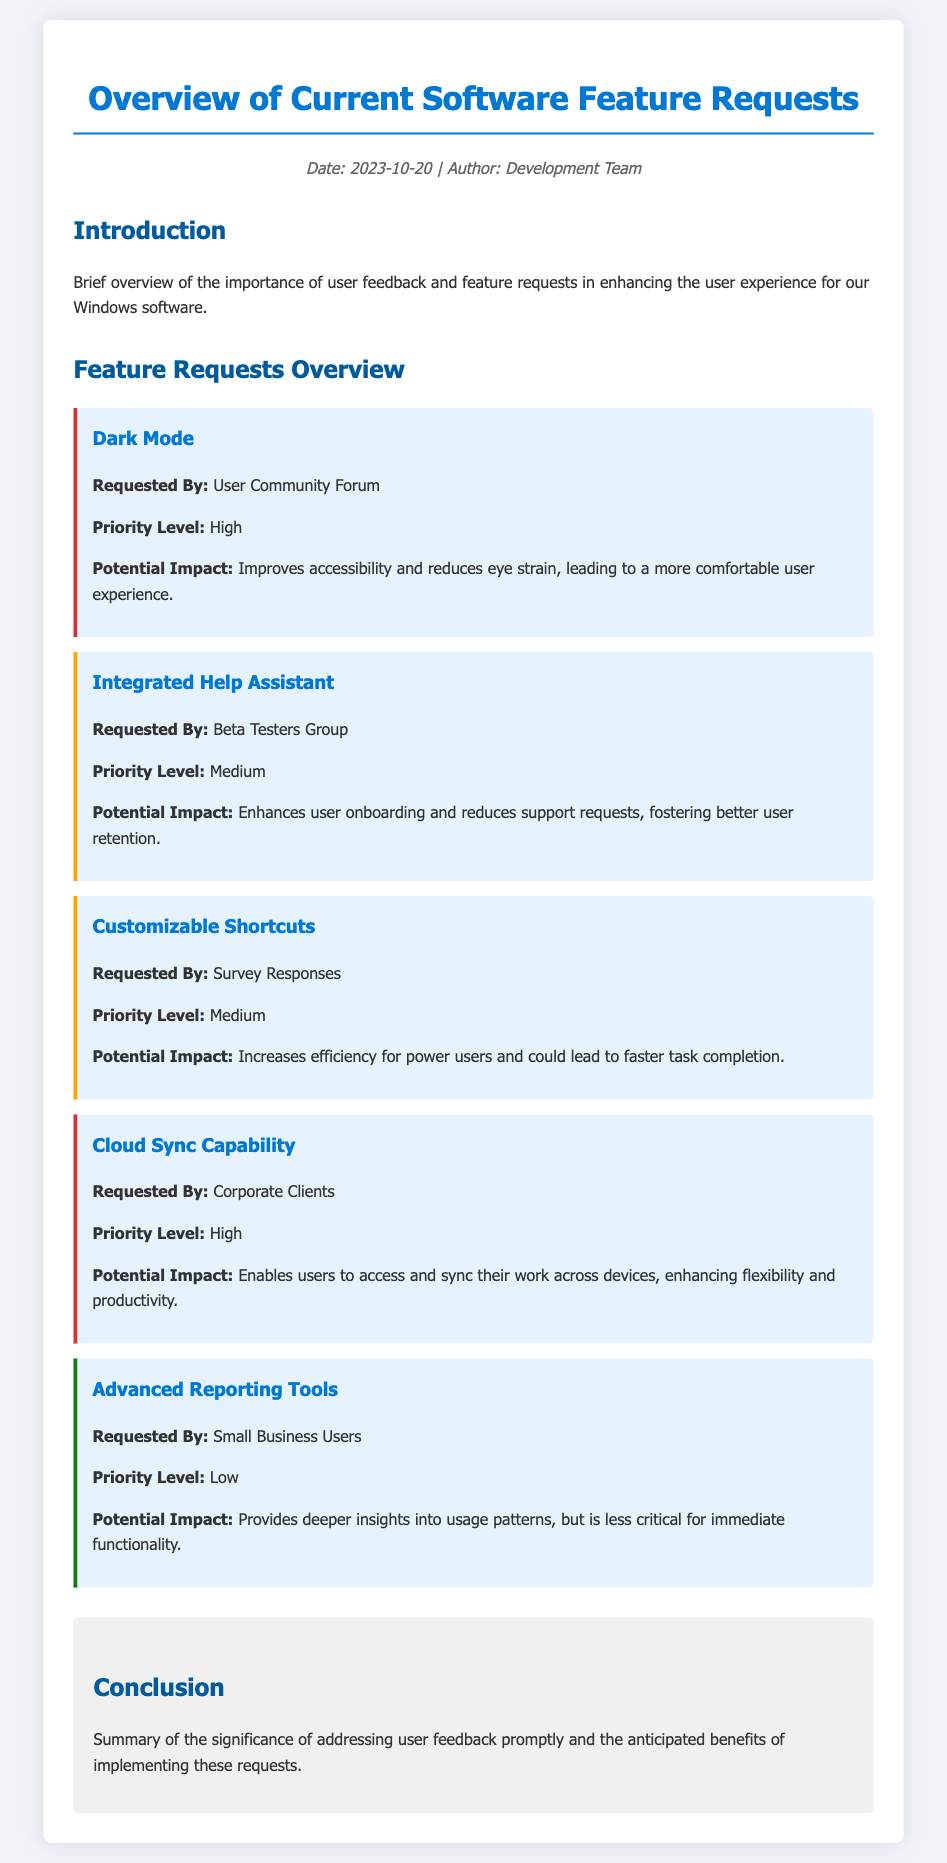What is the date of the document? The date is mentioned in the meta section of the document.
Answer: 2023-10-20 Who requested the Dark Mode feature? The requested by information is provided in the feature request section.
Answer: User Community Forum What is the priority level of the Cloud Sync Capability? The priority level is clearly stated in the feature request section.
Answer: High How many feature requests are listed in total? By counting the feature requests in the document, you can find the total.
Answer: Five What is the potential impact of the Integrated Help Assistant? Potential impacts are described in the feature request section.
Answer: Enhances user onboarding and reduces support requests Which feature request was marked with a low priority level? The document categorizes requests by priority level which helps identify them.
Answer: Advanced Reporting Tools What color represents the high priority features in the document? The style and formatting details can help identify this.
Answer: Red What is the title of the document? The title is presented prominently in the rendered document.
Answer: Overview of Current Software Feature Requests 